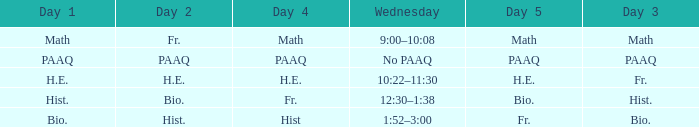What is the day 1 when day 5 is math? Math. 